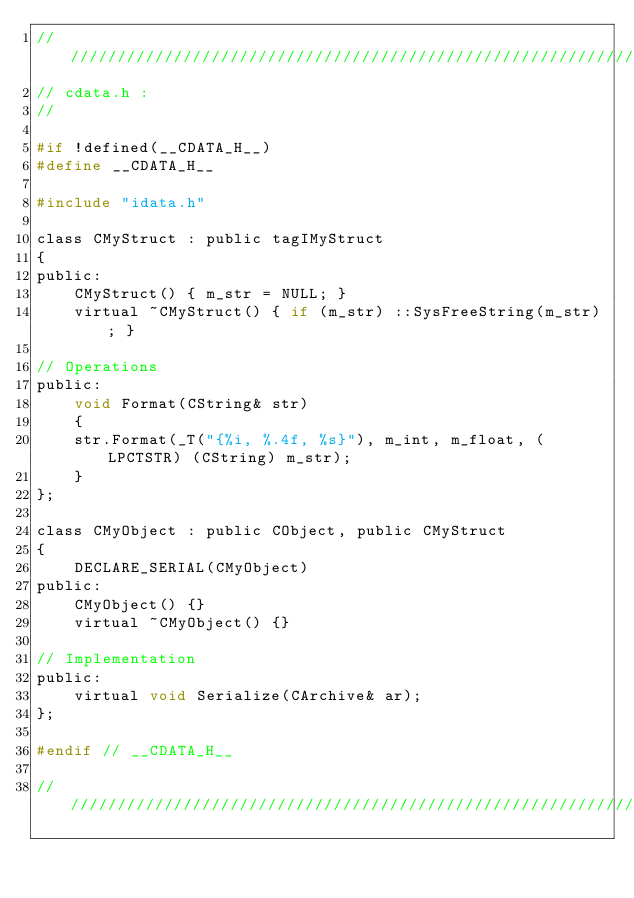Convert code to text. <code><loc_0><loc_0><loc_500><loc_500><_C_>/////////////////////////////////////////////////////////////////////////////
// cdata.h :
//

#if !defined(__CDATA_H__)
#define __CDATA_H__

#include "idata.h"

class CMyStruct : public tagIMyStruct
{
public:
	CMyStruct() { m_str = NULL; }
	virtual ~CMyStruct() { if (m_str) ::SysFreeString(m_str); }

// Operations
public:
	void Format(CString& str)
	{
	str.Format(_T("{%i, %.4f, %s}"), m_int, m_float, (LPCTSTR) (CString) m_str);
	}
};

class CMyObject : public CObject, public CMyStruct
{
	DECLARE_SERIAL(CMyObject)
public:
	CMyObject() {}
	virtual ~CMyObject() {}

// Implementation
public:
	virtual void Serialize(CArchive& ar);
};

#endif // __CDATA_H__

/////////////////////////////////////////////////////////////////////////////
</code> 